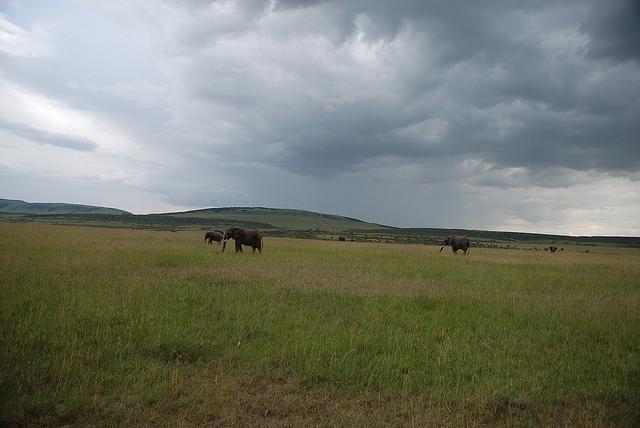How's the weather?
Short answer required. Cloudy. What color are the trees?
Be succinct. Green. What is in the background?
Be succinct. Hills. How many mountains are there?
Concise answer only. 2. What type of grass are they eating?
Write a very short answer. Green grass. Is moisture wanting in this environment?
Concise answer only. No. What made the white streak in the sky?
Write a very short answer. Clouds. Are these horses near a town?
Quick response, please. No. Is it sunny?
Be succinct. No. Is it about to rain?
Be succinct. Yes. What species of animal is closest to the camera?
Be succinct. Elephant. Are these sheep or goats?
Short answer required. Neither. How many horses are there?
Write a very short answer. 0. What images do you see in the clouds?
Quick response, please. Afro. What kind of cloud is in the sky?
Give a very brief answer. Cumulus. What is in the sky?
Give a very brief answer. Clouds. How many animal species are shown?
Answer briefly. 1. What continent do these animals live on?
Give a very brief answer. Africa. Are there leaves on the ground?
Short answer required. No. Does it look like rain is coming?
Concise answer only. Yes. What time of day is it?
Quick response, please. Afternoon. What number of gray clouds are in the sky?
Give a very brief answer. 1. Is the sun shining?
Concise answer only. No. Is the ground green?
Be succinct. Yes. What animal is this?
Write a very short answer. Elephant. Are those mountains or hills?
Keep it brief. Hills. Is there someone riding a horse?
Write a very short answer. No. How many animals are in the field and what type of animal are there?
Write a very short answer. 3 elephants. How many trees are in the field?
Answer briefly. 0. How can you tell it is summer?
Keep it brief. Dry grass. Is this a area with lots of trees?
Short answer required. No. Are the mountains high?
Be succinct. No. 